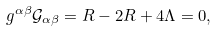Convert formula to latex. <formula><loc_0><loc_0><loc_500><loc_500>g ^ { \alpha \beta } \mathcal { G } _ { \alpha \beta } = R - 2 R + 4 \Lambda = 0 ,</formula> 